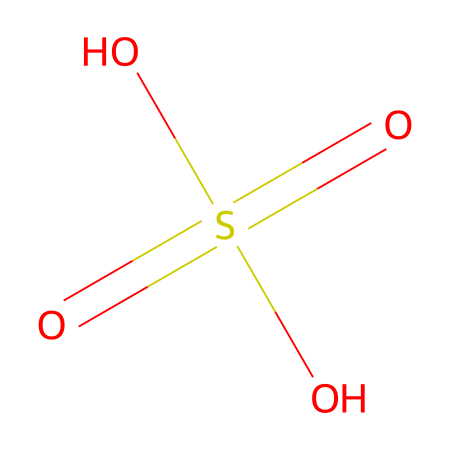How many oxygen atoms are present in this chemical? In the SMILES representation, "O" indicates the presence of oxygen atoms. Counting them in the structure, there are four "O" present.
Answer: four What is the central atom in this compound? The "S" in the SMILES representation indicates sulfur, which is the central atom of the compound.
Answer: sulfur What is the oxidation state of sulfur in this compound? Sulfur is bonded to four oxygen atoms, with double bonds to two of them (as depicted by "=O") and two single bonds to the remaining two ("O"). This configuration indicates that sulfur's oxidation state is +6.
Answer: plus six What type of functional groups are present in this chemical? The presence of "SO4" suggests the sulfate functional group, which is typical in sulfur compounds. The two hydroxyl groups (–OH) indicate the presence of alcohol functional groups, suggesting acidic properties.
Answer: sulfate and alcohol What is the total number of bonds in this molecule? The sulfur is connected via two double bonds and two single bonds to oxygen atoms. In total, there are four bonds indicated in the SMILES representation: two double bonds (4 connections) and two single bonds (2 connections) resulting in a total of 6 bonds.
Answer: six What is the chemical name for this compound? With the structure indicating a sulfur atom bonded to four oxygen atoms, it can be identified as sulfuric acid (H2SO4) based on its known classification in chemistry.
Answer: sulfuric acid 